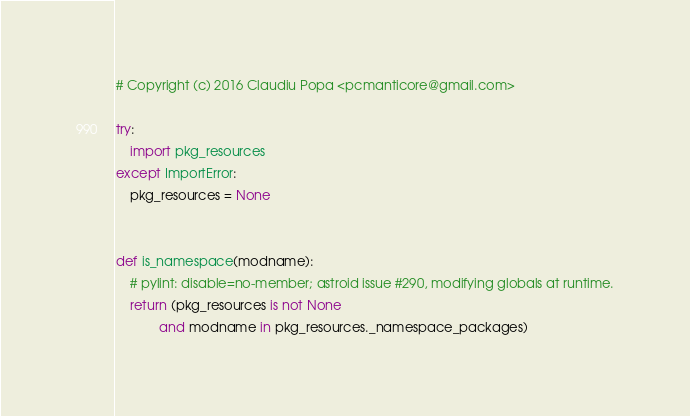Convert code to text. <code><loc_0><loc_0><loc_500><loc_500><_Python_># Copyright (c) 2016 Claudiu Popa <pcmanticore@gmail.com>

try:
    import pkg_resources
except ImportError:
    pkg_resources = None


def is_namespace(modname):
    # pylint: disable=no-member; astroid issue #290, modifying globals at runtime.
    return (pkg_resources is not None
            and modname in pkg_resources._namespace_packages)
</code> 